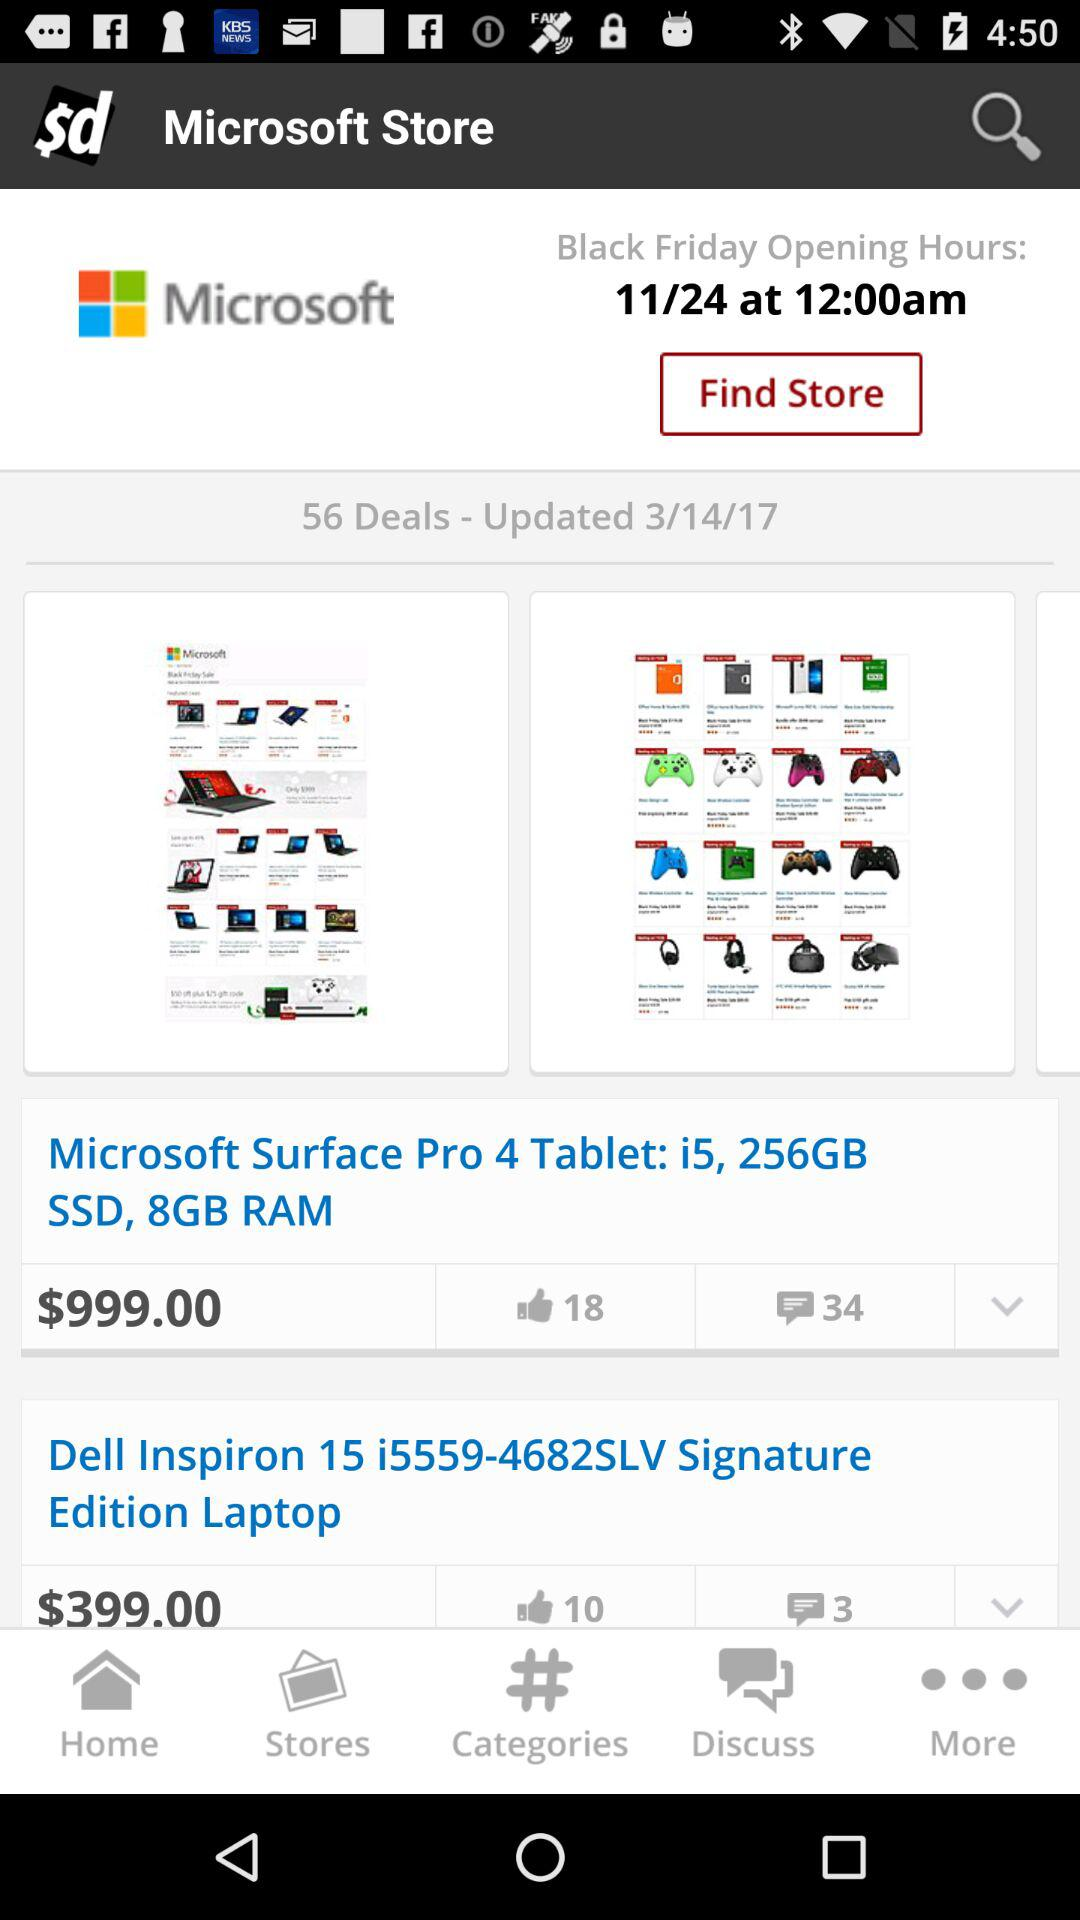How many people like "Microsoft Surface Pro 4 Tablet: i5, 256GB SSD, 8GB RAM"? There are 18 people who like "Microsoft Surface Pro 4 Tablet: i5, 256GB SSD, 8GB RAM". 